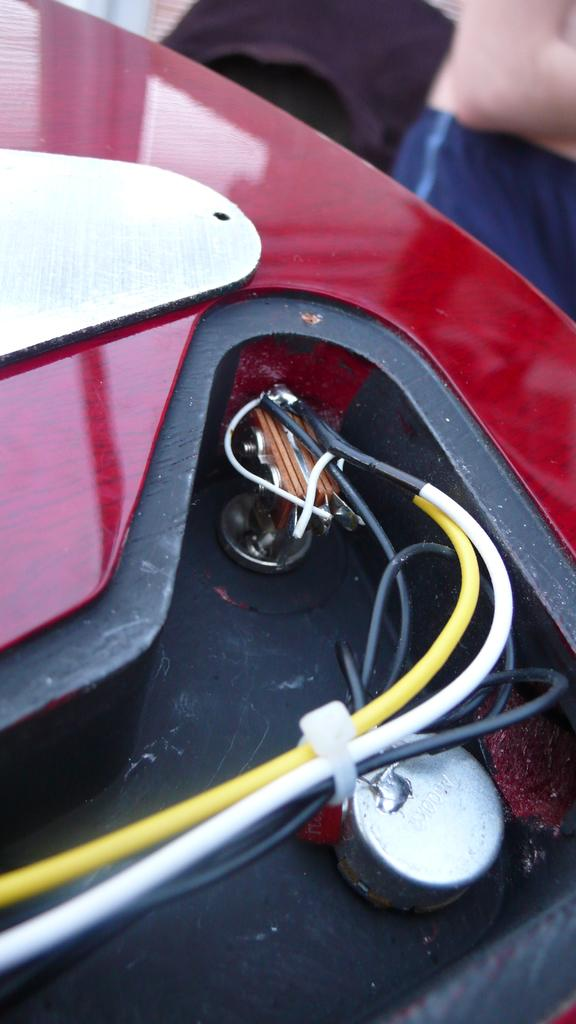What is the color of the object in the image? The object in the image has a red and white color. What else can be seen in the image besides the colorful object? There are wires visible in the image. What type of linen is being used to cover the cabbage in the image? There is no linen or cabbage present in the image. 